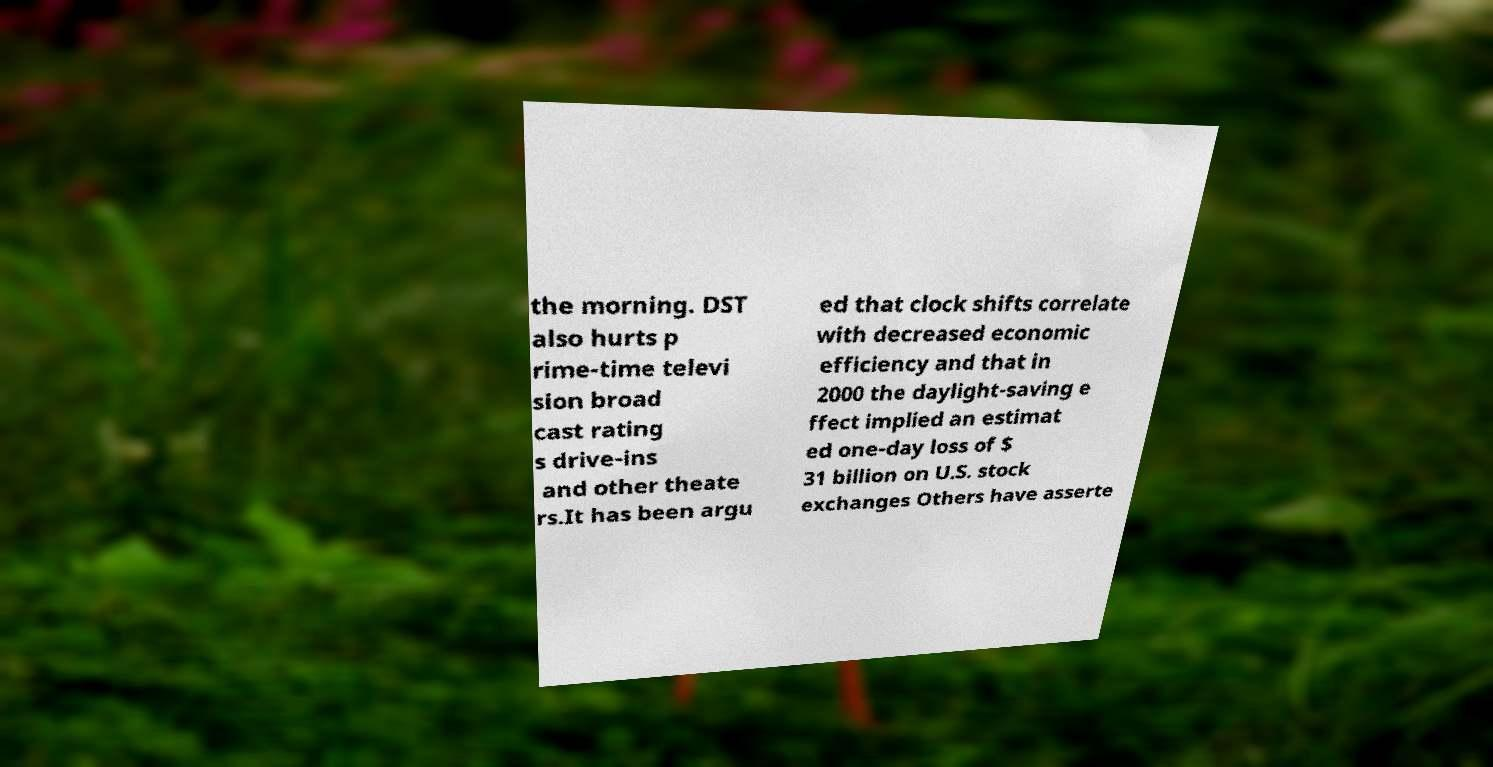Can you read and provide the text displayed in the image?This photo seems to have some interesting text. Can you extract and type it out for me? the morning. DST also hurts p rime-time televi sion broad cast rating s drive-ins and other theate rs.It has been argu ed that clock shifts correlate with decreased economic efficiency and that in 2000 the daylight-saving e ffect implied an estimat ed one-day loss of $ 31 billion on U.S. stock exchanges Others have asserte 